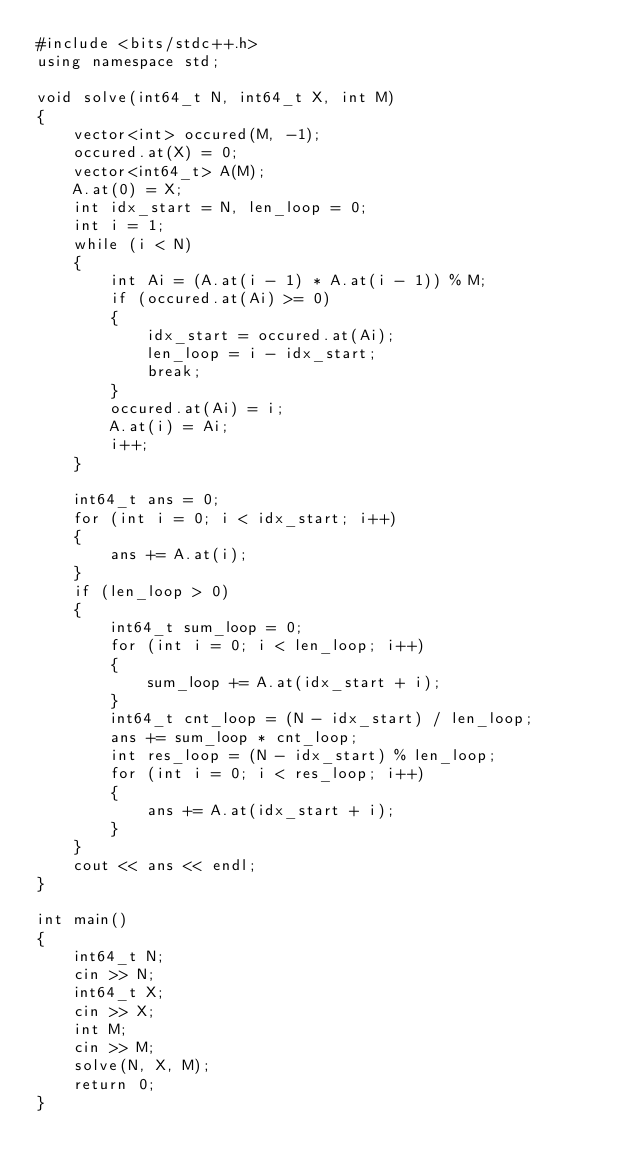Convert code to text. <code><loc_0><loc_0><loc_500><loc_500><_C++_>#include <bits/stdc++.h>
using namespace std;

void solve(int64_t N, int64_t X, int M)
{
    vector<int> occured(M, -1);
    occured.at(X) = 0;
    vector<int64_t> A(M);
    A.at(0) = X;
    int idx_start = N, len_loop = 0;
    int i = 1;
    while (i < N)
    {
        int Ai = (A.at(i - 1) * A.at(i - 1)) % M;
        if (occured.at(Ai) >= 0)
        {
            idx_start = occured.at(Ai);
            len_loop = i - idx_start;
            break;
        }
        occured.at(Ai) = i;
        A.at(i) = Ai;
        i++;
    }

    int64_t ans = 0;
    for (int i = 0; i < idx_start; i++)
    {
        ans += A.at(i);
    }
    if (len_loop > 0)
    {
        int64_t sum_loop = 0;
        for (int i = 0; i < len_loop; i++)
        {
            sum_loop += A.at(idx_start + i);
        }
        int64_t cnt_loop = (N - idx_start) / len_loop;
        ans += sum_loop * cnt_loop;
        int res_loop = (N - idx_start) % len_loop;
        for (int i = 0; i < res_loop; i++)
        {
            ans += A.at(idx_start + i);
        }
    }
    cout << ans << endl;
}

int main()
{
    int64_t N;
    cin >> N;
    int64_t X;
    cin >> X;
    int M;
    cin >> M;
    solve(N, X, M);
    return 0;
}
</code> 